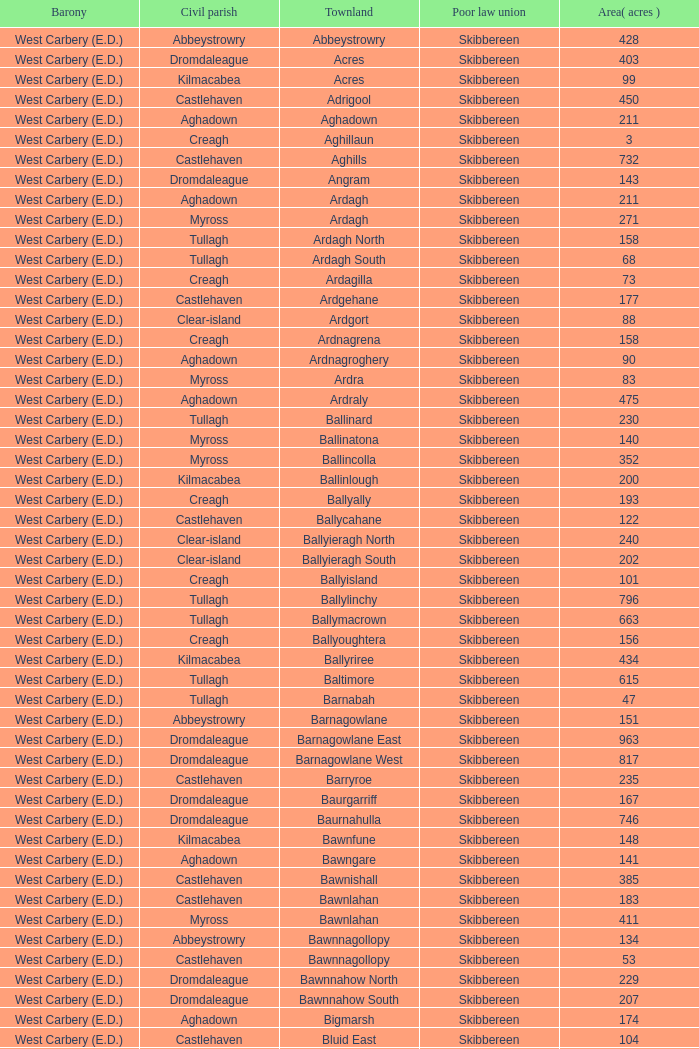What are the Poor Law Unions when the area (in acres) is 142? Skibbereen. 